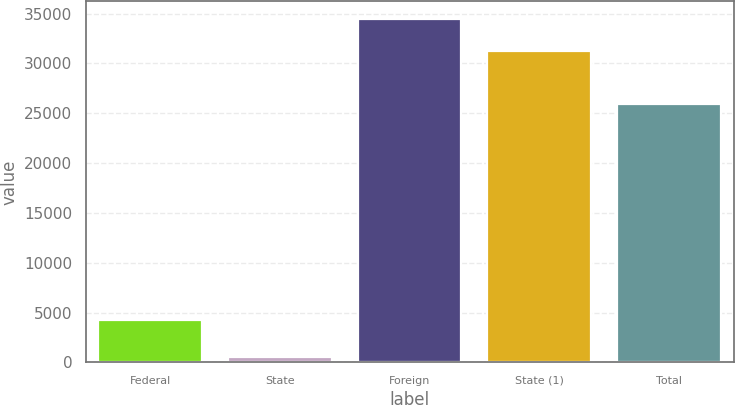<chart> <loc_0><loc_0><loc_500><loc_500><bar_chart><fcel>Federal<fcel>State<fcel>Foreign<fcel>State (1)<fcel>Total<nl><fcel>4285<fcel>541<fcel>34509.5<fcel>31229<fcel>25983<nl></chart> 